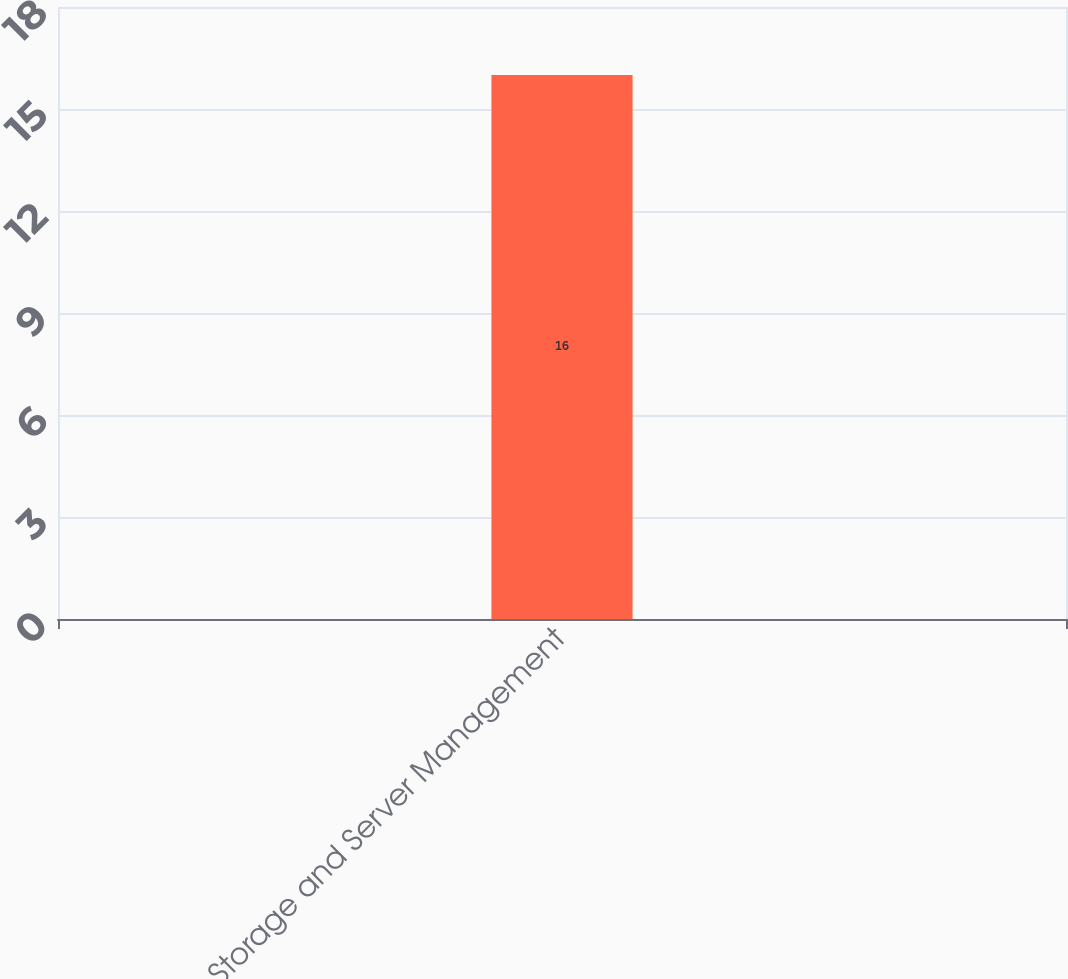Convert chart. <chart><loc_0><loc_0><loc_500><loc_500><bar_chart><fcel>Storage and Server Management<nl><fcel>16<nl></chart> 